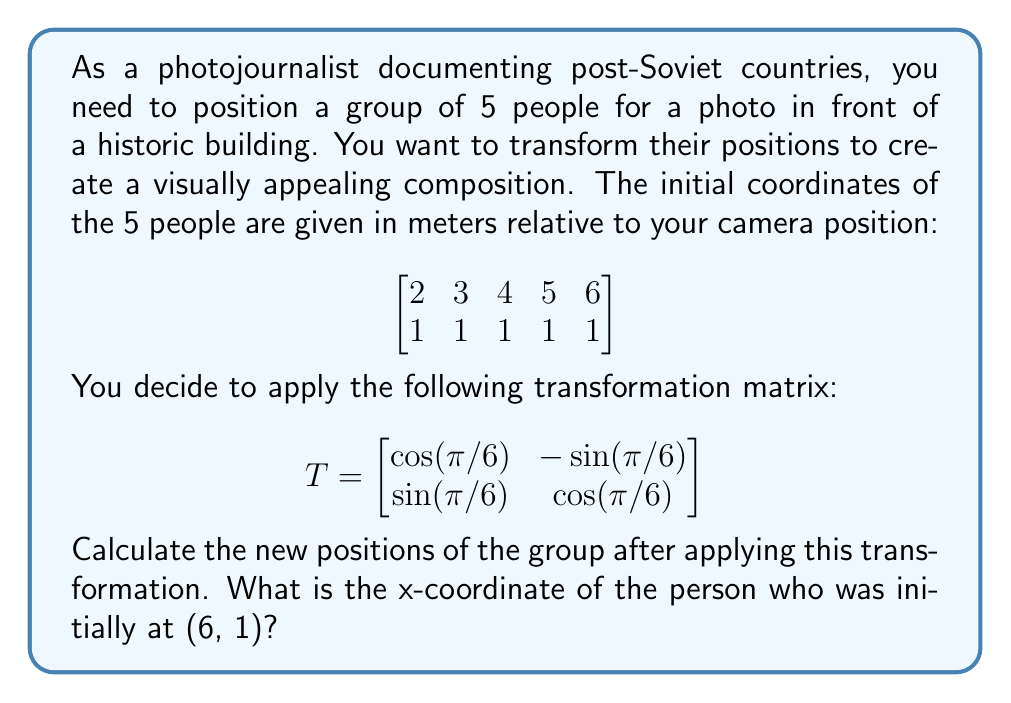Solve this math problem. Let's approach this step-by-step:

1) The transformation matrix $T$ is a rotation matrix that rotates points by $\pi/6$ radians (or 30 degrees) counterclockwise.

2) To apply this transformation, we need to multiply the matrix $T$ by each column of our initial position matrix. Let's call our initial position matrix $P$.

3) The resulting matrix will be $TP$:

   $$TP = \begin{bmatrix}
   \cos(\pi/6) & -\sin(\pi/6) \\
   \sin(\pi/6) & \cos(\pi/6)
   \end{bmatrix} \begin{bmatrix}
   2 & 3 & 4 & 5 & 6 \\
   1 & 1 & 1 & 1 & 1
   \end{bmatrix}$$

4) Let's calculate the values of $\cos(\pi/6)$ and $\sin(\pi/6)$:
   
   $\cos(\pi/6) = \frac{\sqrt{3}}{2} \approx 0.866$
   $\sin(\pi/6) = \frac{1}{2} = 0.5$

5) Now we can perform the matrix multiplication:

   $$TP = \begin{bmatrix}
   0.866 & -0.5 \\
   0.5 & 0.866
   \end{bmatrix} \begin{bmatrix}
   2 & 3 & 4 & 5 & 6 \\
   1 & 1 & 1 & 1 & 1
   \end{bmatrix}$$

6) For the person initially at (6, 1), we need to calculate:

   $$\begin{bmatrix}
   0.866 & -0.5 \\
   0.5 & 0.866
   \end{bmatrix} \begin{bmatrix}
   6 \\
   1
   \end{bmatrix}$$

7) This gives us:

   $$\begin{bmatrix}
   0.866 * 6 + (-0.5) * 1 \\
   0.5 * 6 + 0.866 * 1
   \end{bmatrix} = \begin{bmatrix}
   4.696 \\
   3.866
   \end{bmatrix}$$

8) The x-coordinate of this person after the transformation is approximately 4.696 meters.
Answer: 4.696 meters 